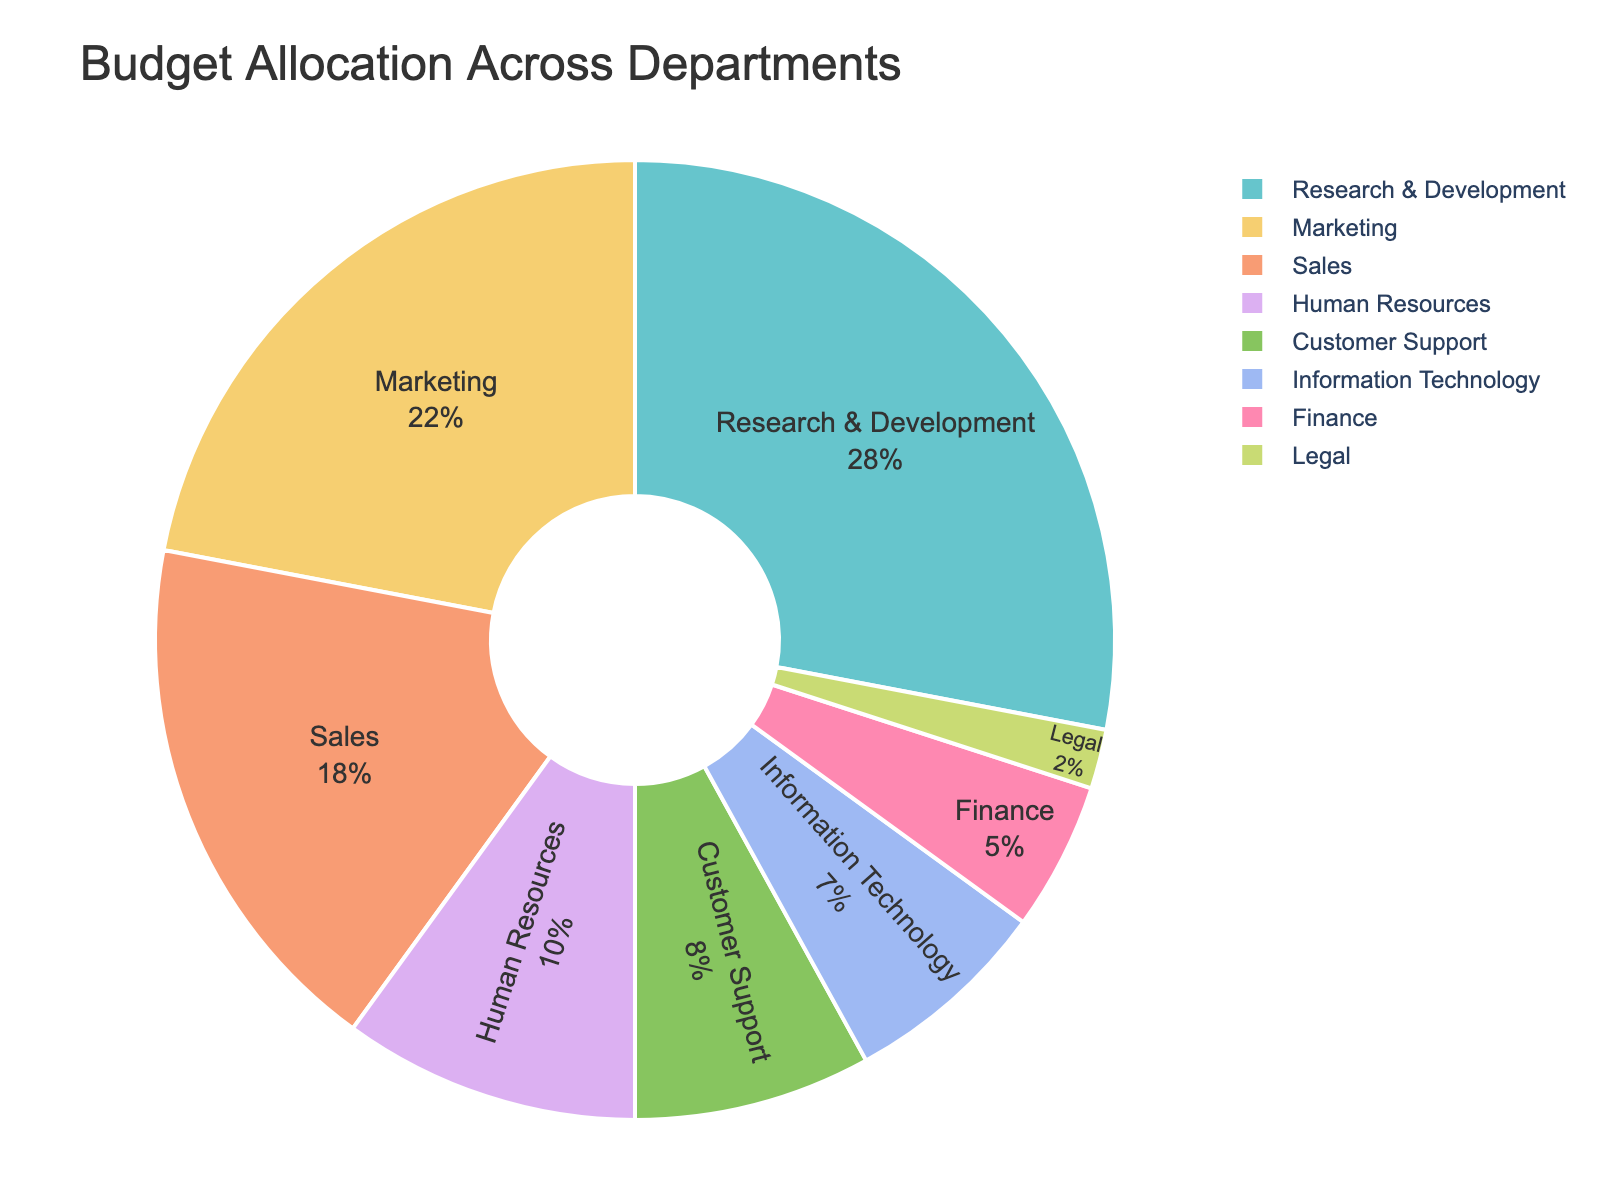What's the largest budget allocation across all departments? To find the largest budget allocation, identify the sector with the highest percentage from the pie chart. The "Research & Development" department has the highest allocation.
Answer: Research & Development What percentage of the budget is allocated to Customer Support and Finance departments combined? Add the budget allocations for Customer Support (8%) and Finance (5%) as indicated on the chart. The combined allocation is 13%.
Answer: 13% Which department receives the least budget allocation? Look for the smallest sector in the pie chart. The "Legal" department has the smallest percentage at 2%.
Answer: Legal Is the budget allocation for Sales greater than that for Marketing? Compare the percentages for Sales (18%) and Marketing (22%) from the pie chart. Sales has a smaller allocation than Marketing.
Answer: No How much more budget percentage does Marketing receive compared to Information Technology? Subtract the budget allocation of Information Technology (7%) from that of Marketing (22%). The difference is 15%.
Answer: 15% Which departments receive a combined budget allocation of exactly 10%? From the chart, Human Resources alone has a budget allocation of 10%.
Answer: Human Resources Is the combined budget allocation for Information Technology and Customer Support more than that for Sales? Add the percentages for Information Technology (7%) and Customer Support (8%) which sum to 15%, then compare it to the Sales allocation of 18%. Sales has a larger allocation.
Answer: No What is the sum of the budget allocations for departments other than Research & Development, Marketing, and Sales? First calculate the sum of the excluded departments (Research & Development = 28%, Marketing = 22%, and Sales = 18%) which is 68%. Then subtract this from 100% to get the combined budget for the remaining departments: 100% - 68% = 32%. Alternatively, sum Customer Support (8%), Human Resources (10%), Information Technology (7%), Finance (5%), and Legal (2%) which totals 32%.
Answer: 32% What is the difference in budget allocation between the highest and lowest funded departments? Subtract the budget allocation of the lowest funded department, Legal (2%), from the highest funded department, Research & Development (28%). The difference is 26%.
Answer: 26% What combined percentage of the budget is allocated to Human Resources, Customer Support, and Finance? Add the percentages from the pie chart: Human Resources (10%), Customer Support (8%), and Finance (5%) which totals 23%.
Answer: 23% 